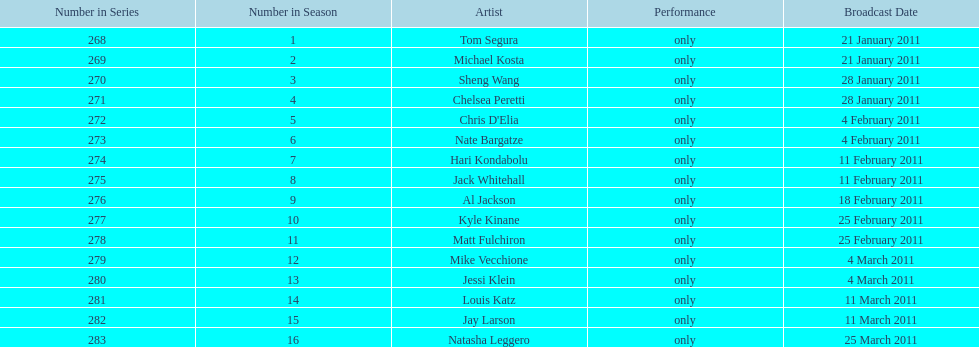How many different performers appeared during this season? 16. 